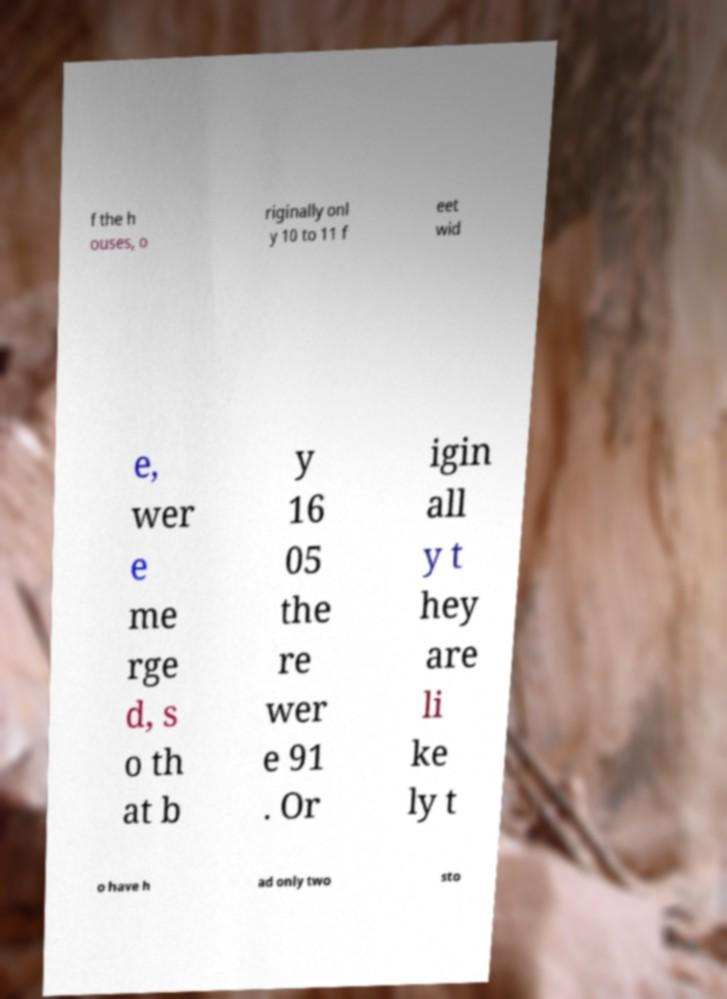Could you extract and type out the text from this image? f the h ouses, o riginally onl y 10 to 11 f eet wid e, wer e me rge d, s o th at b y 16 05 the re wer e 91 . Or igin all y t hey are li ke ly t o have h ad only two sto 